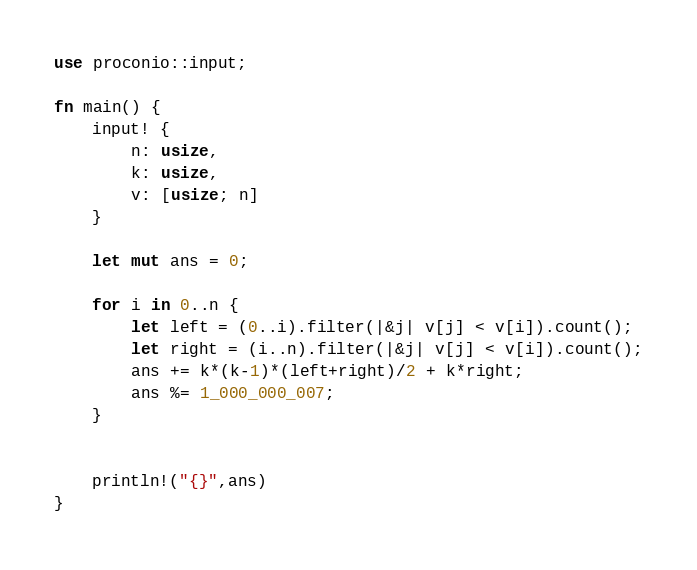<code> <loc_0><loc_0><loc_500><loc_500><_Rust_>use proconio::input;

fn main() {
    input! {
        n: usize,
        k: usize,
        v: [usize; n]
    }

    let mut ans = 0;

    for i in 0..n {
        let left = (0..i).filter(|&j| v[j] < v[i]).count();
        let right = (i..n).filter(|&j| v[j] < v[i]).count();
        ans += k*(k-1)*(left+right)/2 + k*right;
        ans %= 1_000_000_007;
    }


    println!("{}",ans)
}</code> 